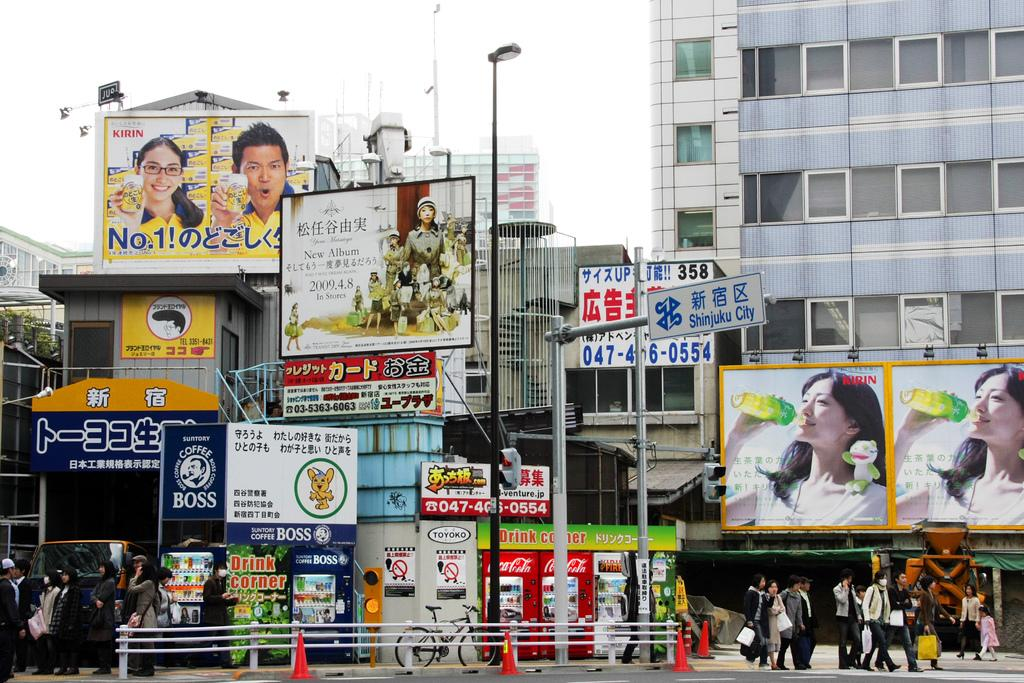What type of structures can be seen in the image? There are buildings in the image. What additional objects are present in the image? There are banners, a bicycle, traffic cones, a group of people, a street lamp, and traffic signals in the image. Can you describe the presence of the group of people in the image? There is a group of people in the image, but their specific actions or activities are not clear. What is visible at the top of the image? The sky is visible at the top of the image. What type of party is being held in the image? There is no indication of a party in the image. The image features buildings, banners, a bicycle, traffic cones, a group of people, a street lamp, and traffic signals, but no party-related elements are present. 